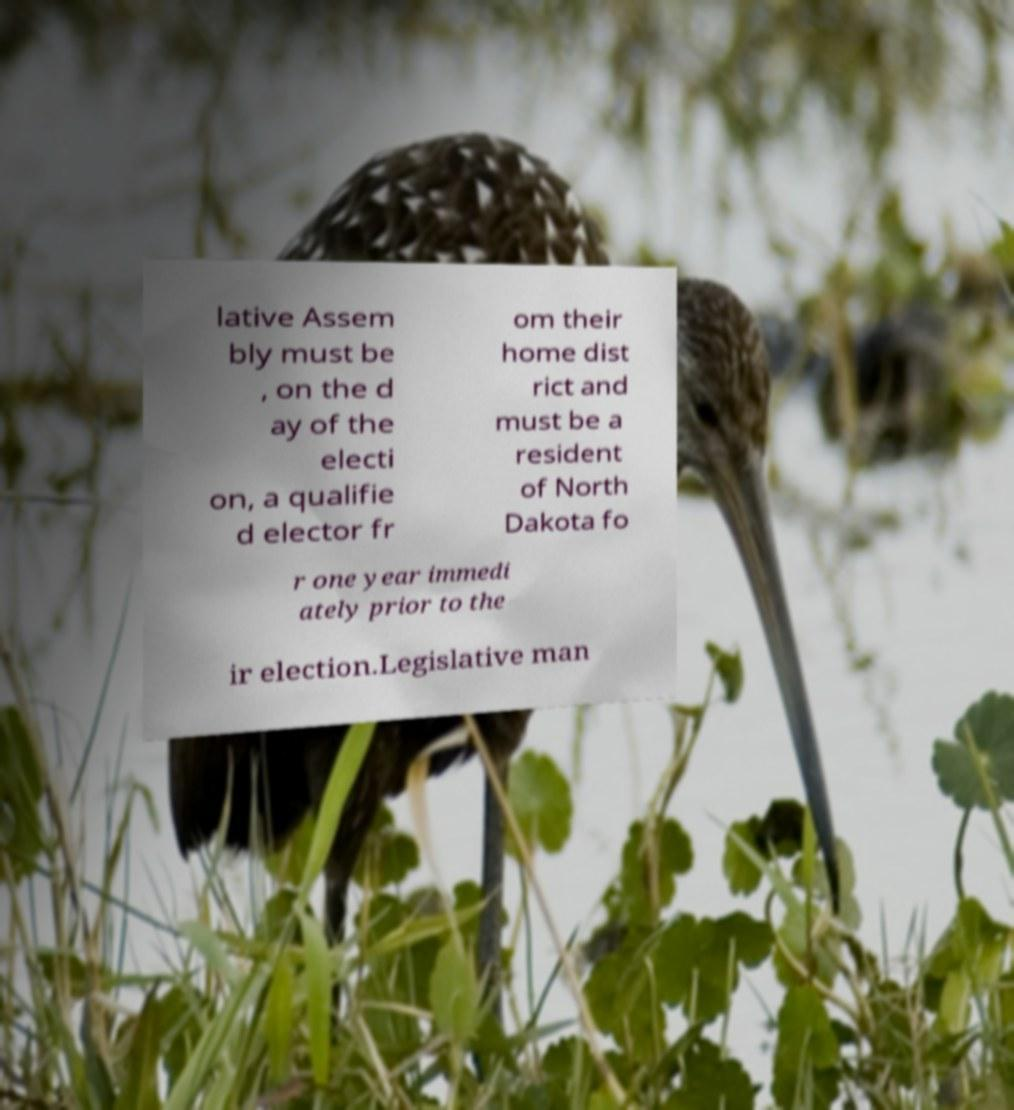Please read and relay the text visible in this image. What does it say? lative Assem bly must be , on the d ay of the electi on, a qualifie d elector fr om their home dist rict and must be a resident of North Dakota fo r one year immedi ately prior to the ir election.Legislative man 